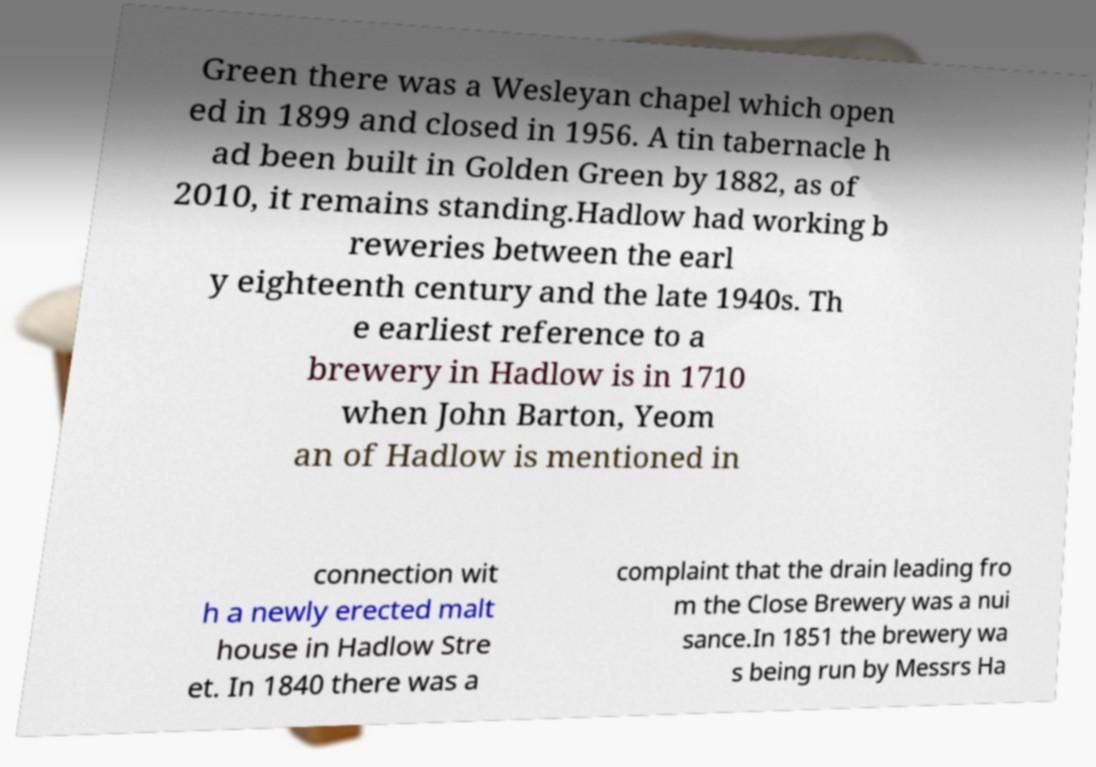Please read and relay the text visible in this image. What does it say? Green there was a Wesleyan chapel which open ed in 1899 and closed in 1956. A tin tabernacle h ad been built in Golden Green by 1882, as of 2010, it remains standing.Hadlow had working b reweries between the earl y eighteenth century and the late 1940s. Th e earliest reference to a brewery in Hadlow is in 1710 when John Barton, Yeom an of Hadlow is mentioned in connection wit h a newly erected malt house in Hadlow Stre et. In 1840 there was a complaint that the drain leading fro m the Close Brewery was a nui sance.In 1851 the brewery wa s being run by Messrs Ha 